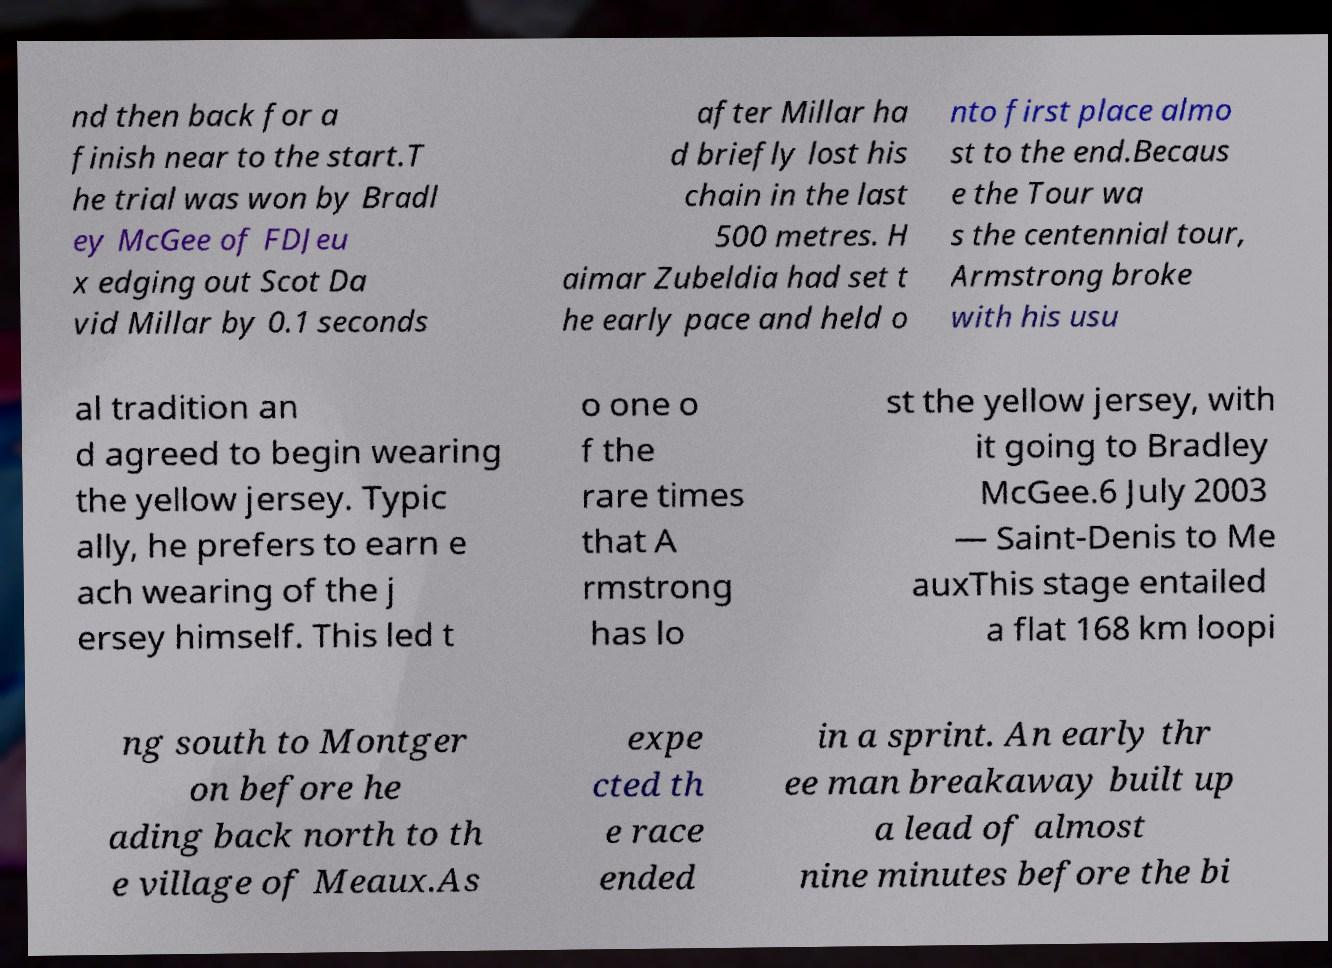Could you extract and type out the text from this image? nd then back for a finish near to the start.T he trial was won by Bradl ey McGee of FDJeu x edging out Scot Da vid Millar by 0.1 seconds after Millar ha d briefly lost his chain in the last 500 metres. H aimar Zubeldia had set t he early pace and held o nto first place almo st to the end.Becaus e the Tour wa s the centennial tour, Armstrong broke with his usu al tradition an d agreed to begin wearing the yellow jersey. Typic ally, he prefers to earn e ach wearing of the j ersey himself. This led t o one o f the rare times that A rmstrong has lo st the yellow jersey, with it going to Bradley McGee.6 July 2003 — Saint-Denis to Me auxThis stage entailed a flat 168 km loopi ng south to Montger on before he ading back north to th e village of Meaux.As expe cted th e race ended in a sprint. An early thr ee man breakaway built up a lead of almost nine minutes before the bi 